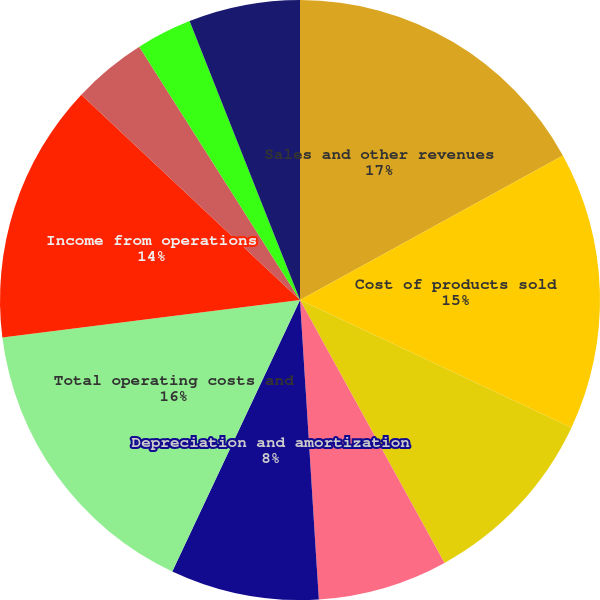Convert chart to OTSL. <chart><loc_0><loc_0><loc_500><loc_500><pie_chart><fcel>Sales and other revenues<fcel>Cost of products sold<fcel>Operating expenses (exclusive<fcel>General and administrative<fcel>Depreciation and amortization<fcel>Total operating costs and<fcel>Income from operations<fcel>Earnings (loss) of equity<fcel>Interest income<fcel>Interest expense<nl><fcel>17.0%<fcel>15.0%<fcel>10.0%<fcel>7.0%<fcel>8.0%<fcel>16.0%<fcel>14.0%<fcel>4.0%<fcel>3.0%<fcel>6.0%<nl></chart> 